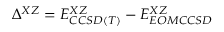Convert formula to latex. <formula><loc_0><loc_0><loc_500><loc_500>\Delta ^ { X Z } = E _ { C C S D ( T ) } ^ { X Z } - E _ { E O M C C S D } ^ { X Z }</formula> 